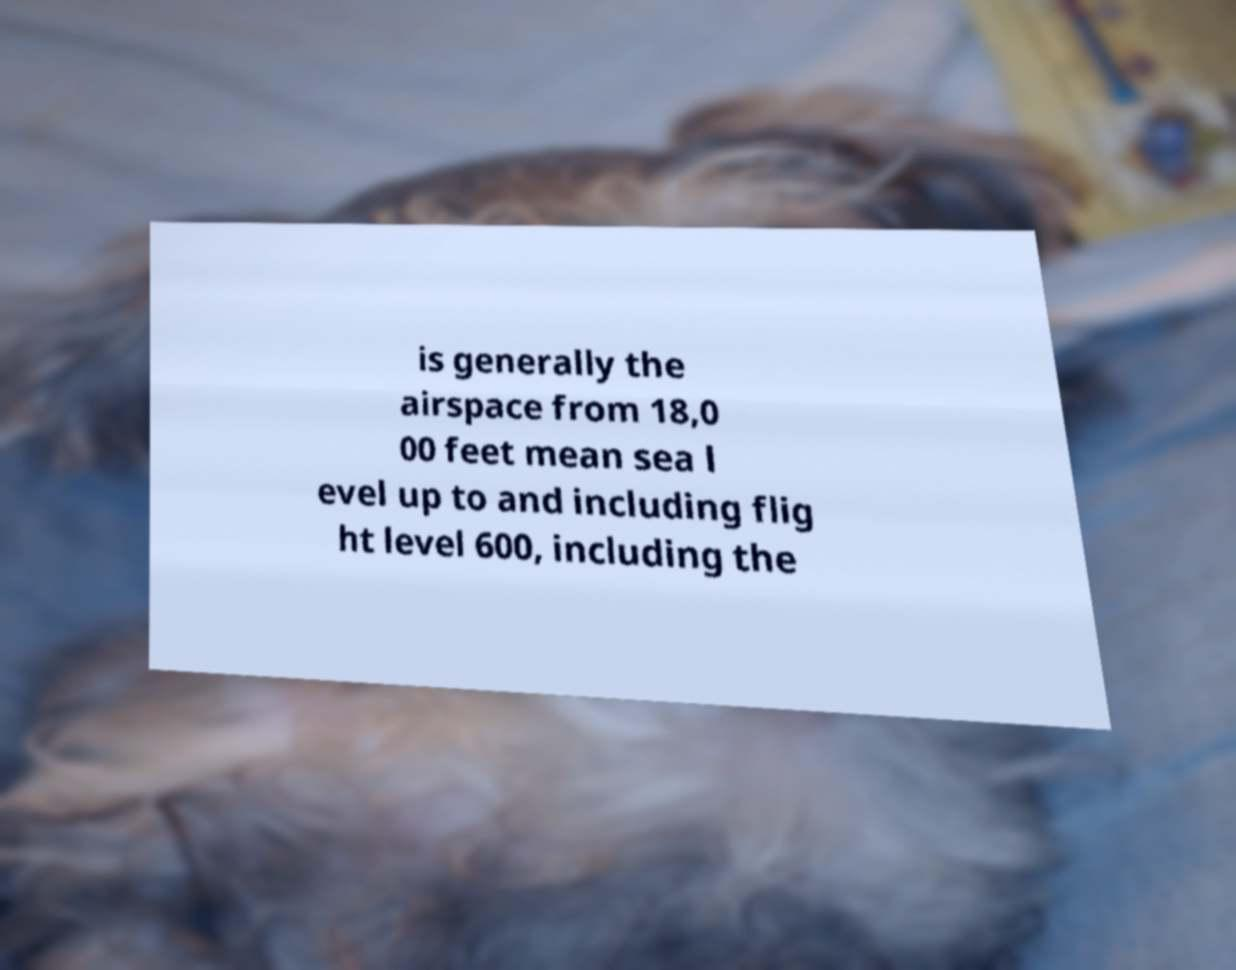Could you assist in decoding the text presented in this image and type it out clearly? is generally the airspace from 18,0 00 feet mean sea l evel up to and including flig ht level 600, including the 